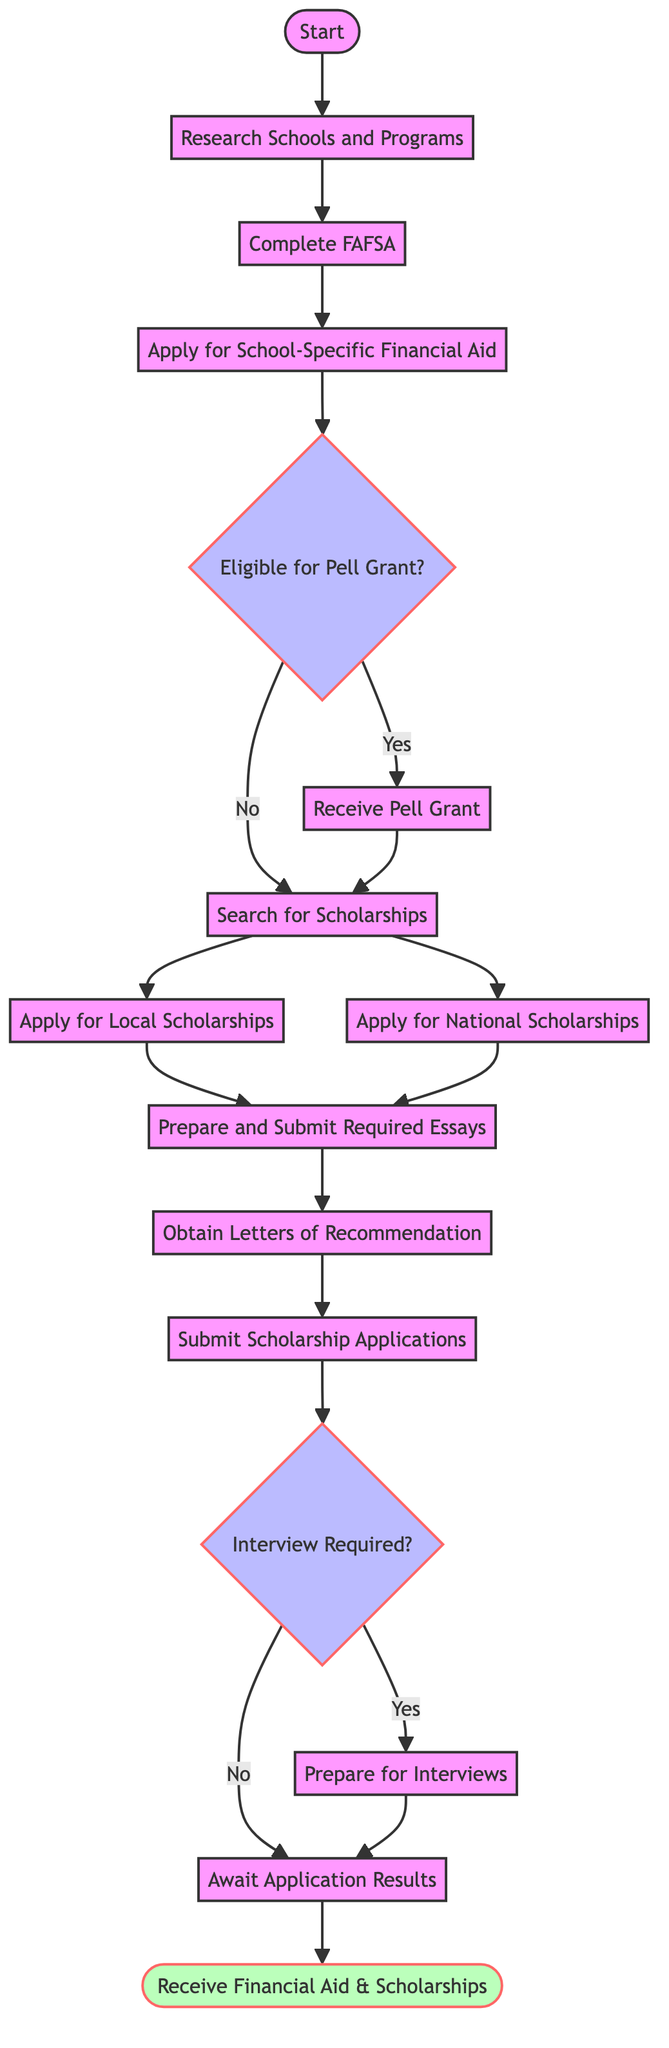What is the first step in this flow chart? The first step in the flow chart is "Start," which is depicted as the starting point of the process.
Answer: Start How many actions are present in the diagram? The diagram contains six actions including "Research Schools and Programs," "Complete FAFSA," "Apply for School-Specific Financial Aid," "Receive Pell Grant," "Search for Scholarships," and "Submit Scholarship Applications."
Answer: Six What does the flow from the "Pell Grant" decision node indicate if the answer is "No"? If the answer to the "Pell Grant" decision node is "No," the flow goes to "Search for Scholarships," indicating the next step a student would take if they are not eligible for a Pell Grant.
Answer: Search for Scholarships What must a student do after applying for local and national scholarships? After applying for local and national scholarships, a student must prepare and submit required essays as the next step in the process.
Answer: Prepare and Submit Required Essays What is the final outcome of the flow chart? The final outcome, represented by the last node in the diagram, is "Receive Financial Aid & Scholarships," which indicates the completion of the process.
Answer: Receive Financial Aid & Scholarships What happens if an interview is required after submitting scholarship applications? If an interview is required, the flow goes to the "Prepare for Interviews" action, meaning the student must prepare before attending any interviews.
Answer: Prepare for Interviews What action follows obtaining letters of recommendation? After obtaining letters of recommendation, the next action is to submit scholarship applications, which is necessary to move forward in securing financial aid.
Answer: Submit Scholarship Applications How does eligibility for the Pell Grant determine the next steps? The eligibility for the Pell Grant determines the flow: if "Yes," the flow proceeds to "Receive Pell Grant"; if "No," it shifts to "Search for Scholarships," indicating a bifurcation in the process based on grant eligibility.
Answer: Yes or No 